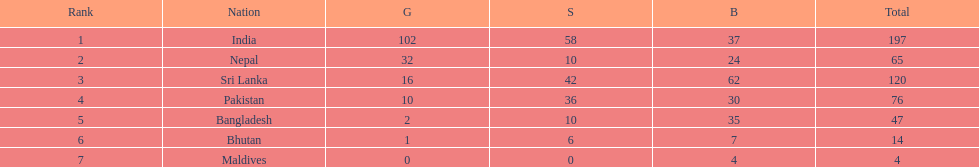Write the full table. {'header': ['Rank', 'Nation', 'G', 'S', 'B', 'Total'], 'rows': [['1', 'India', '102', '58', '37', '197'], ['2', 'Nepal', '32', '10', '24', '65'], ['3', 'Sri Lanka', '16', '42', '62', '120'], ['4', 'Pakistan', '10', '36', '30', '76'], ['5', 'Bangladesh', '2', '10', '35', '47'], ['6', 'Bhutan', '1', '6', '7', '14'], ['7', 'Maldives', '0', '0', '4', '4']]} What nations took part in 1999 south asian games? India, Nepal, Sri Lanka, Pakistan, Bangladesh, Bhutan, Maldives. Of those who earned gold medals? India, Nepal, Sri Lanka, Pakistan, Bangladesh, Bhutan. Which nation didn't earn any gold medals? Maldives. 